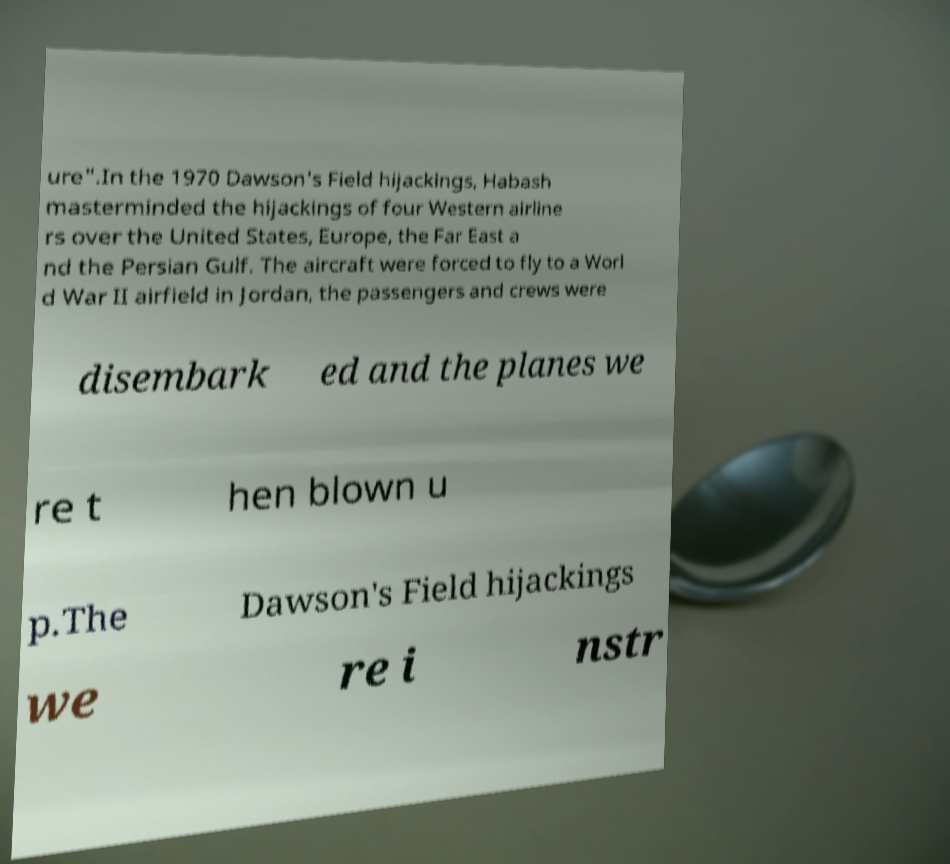Could you extract and type out the text from this image? ure".In the 1970 Dawson's Field hijackings, Habash masterminded the hijackings of four Western airline rs over the United States, Europe, the Far East a nd the Persian Gulf. The aircraft were forced to fly to a Worl d War II airfield in Jordan, the passengers and crews were disembark ed and the planes we re t hen blown u p.The Dawson's Field hijackings we re i nstr 